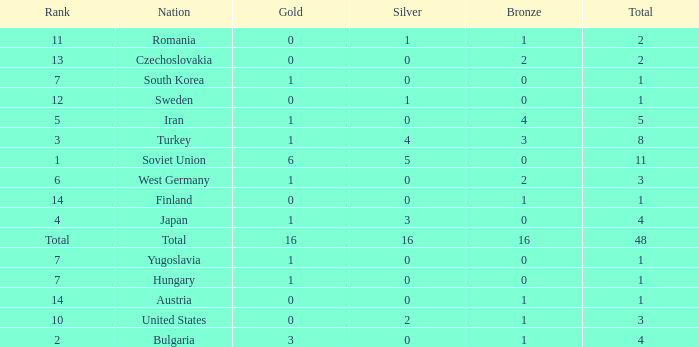How many total golds do teams have when the total medals is less than 1? None. 